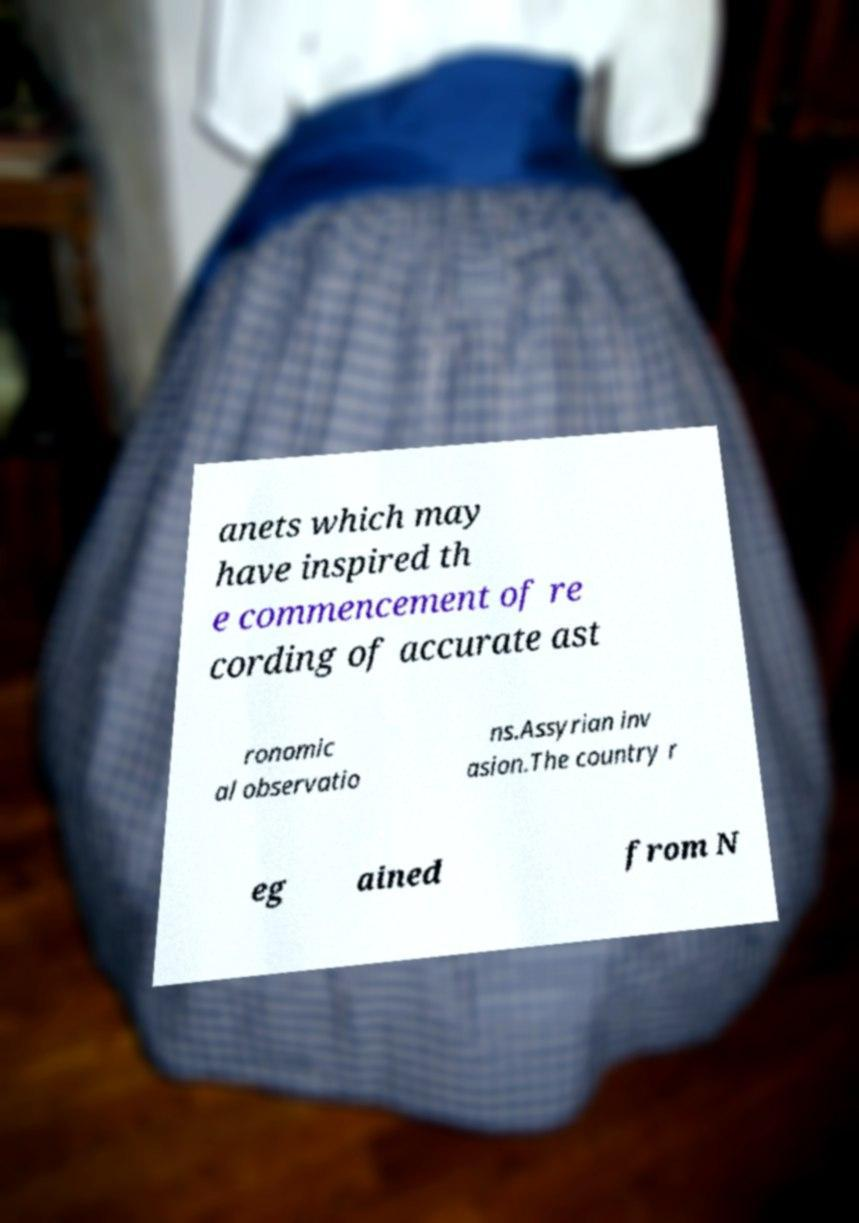Could you assist in decoding the text presented in this image and type it out clearly? anets which may have inspired th e commencement of re cording of accurate ast ronomic al observatio ns.Assyrian inv asion.The country r eg ained from N 